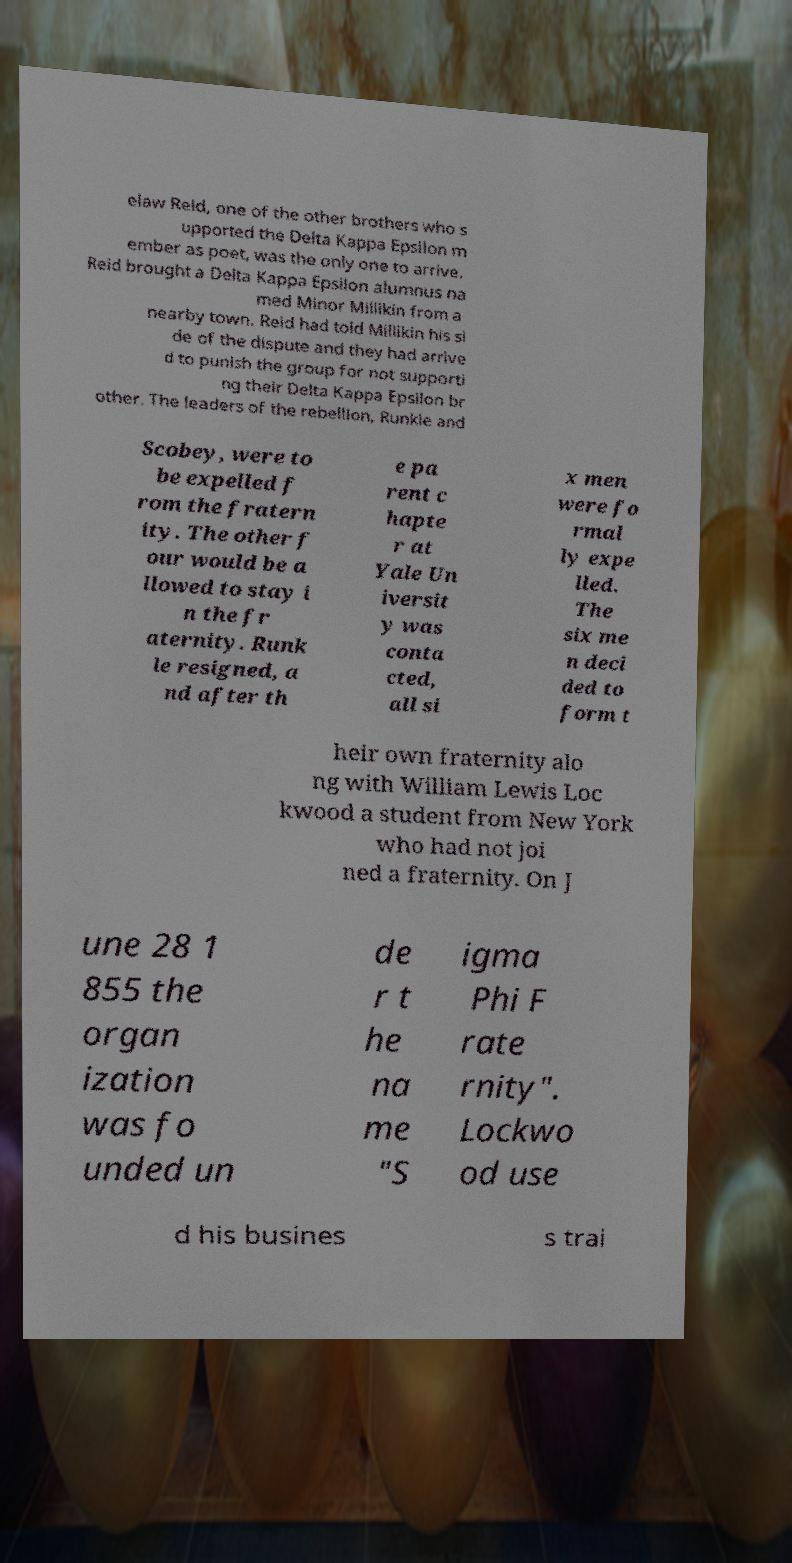Can you read and provide the text displayed in the image?This photo seems to have some interesting text. Can you extract and type it out for me? elaw Reid, one of the other brothers who s upported the Delta Kappa Epsilon m ember as poet, was the only one to arrive. Reid brought a Delta Kappa Epsilon alumnus na med Minor Millikin from a nearby town. Reid had told Millikin his si de of the dispute and they had arrive d to punish the group for not supporti ng their Delta Kappa Epsilon br other. The leaders of the rebellion, Runkle and Scobey, were to be expelled f rom the fratern ity. The other f our would be a llowed to stay i n the fr aternity. Runk le resigned, a nd after th e pa rent c hapte r at Yale Un iversit y was conta cted, all si x men were fo rmal ly expe lled. The six me n deci ded to form t heir own fraternity alo ng with William Lewis Loc kwood a student from New York who had not joi ned a fraternity. On J une 28 1 855 the organ ization was fo unded un de r t he na me "S igma Phi F rate rnity". Lockwo od use d his busines s trai 